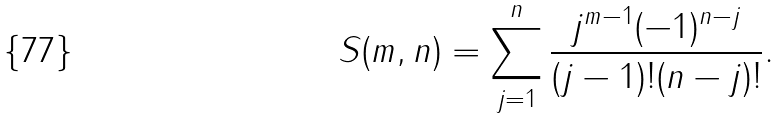<formula> <loc_0><loc_0><loc_500><loc_500>S ( m , n ) = \sum _ { j = 1 } ^ { n } \frac { j ^ { m - 1 } ( - 1 ) ^ { n - j } } { ( j - 1 ) ! ( n - j ) ! } .</formula> 